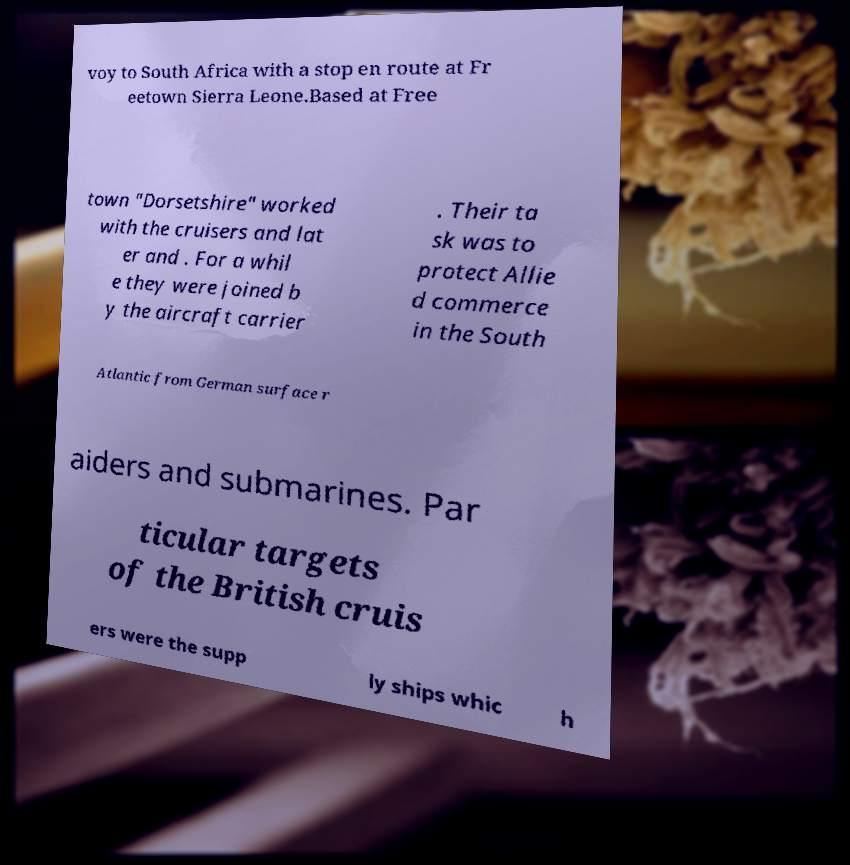I need the written content from this picture converted into text. Can you do that? voy to South Africa with a stop en route at Fr eetown Sierra Leone.Based at Free town "Dorsetshire" worked with the cruisers and lat er and . For a whil e they were joined b y the aircraft carrier . Their ta sk was to protect Allie d commerce in the South Atlantic from German surface r aiders and submarines. Par ticular targets of the British cruis ers were the supp ly ships whic h 